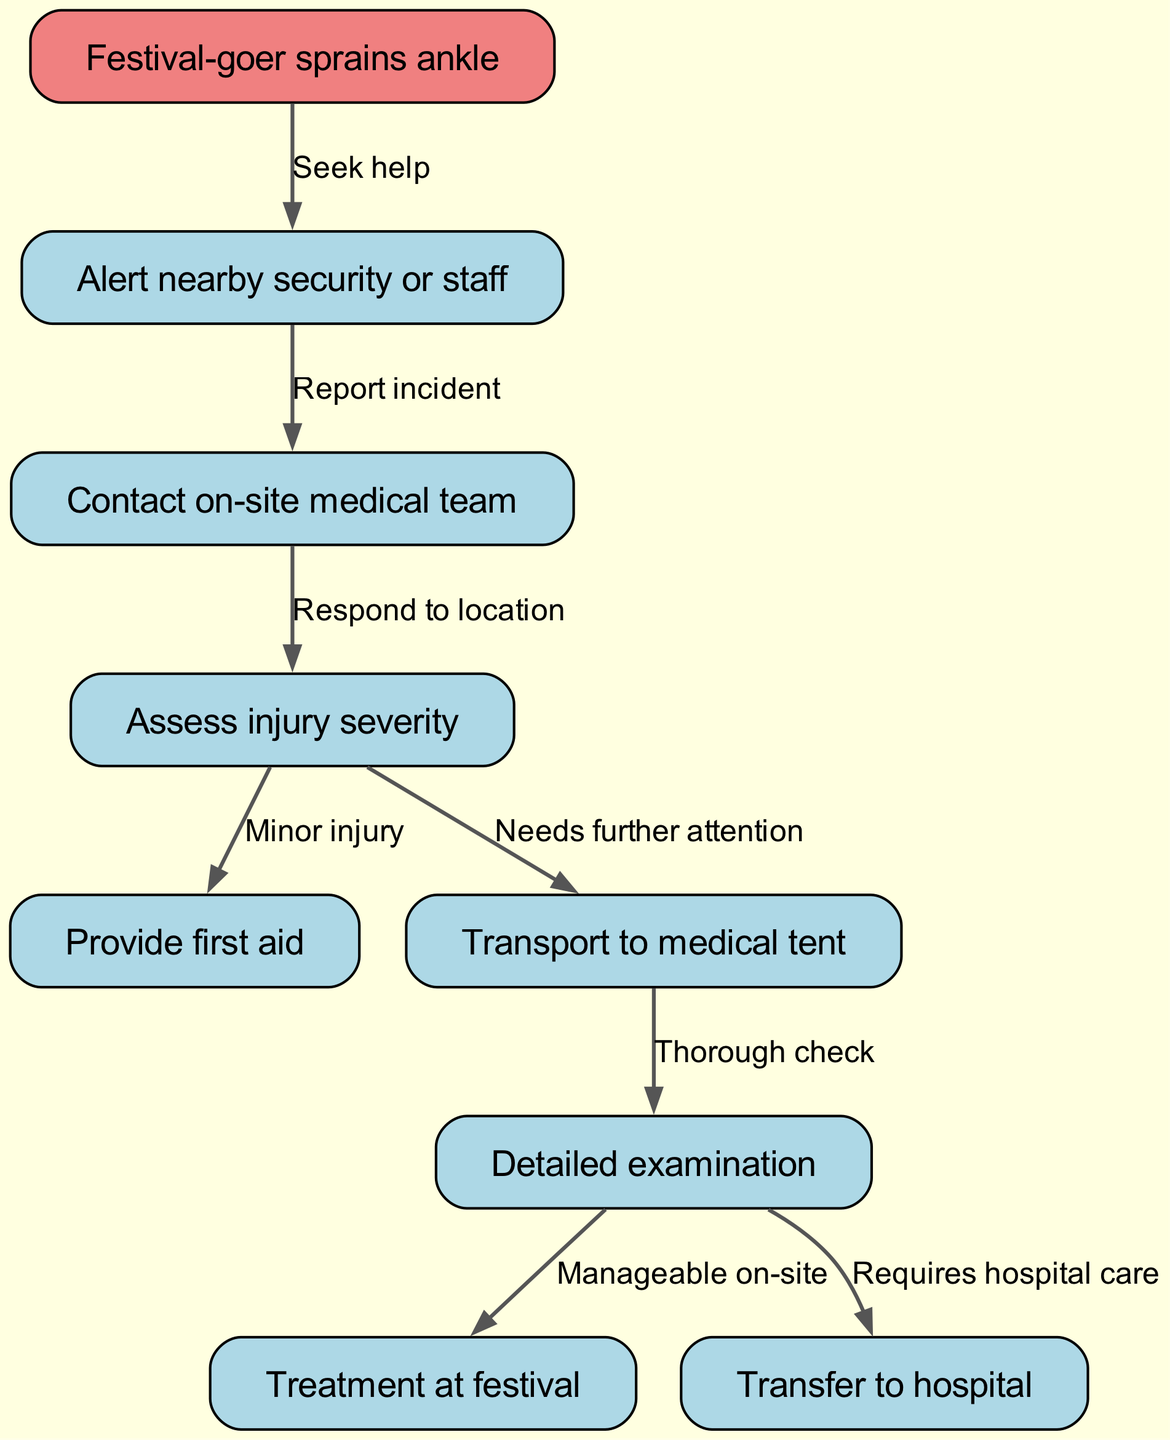What is the first step after a festival-goer sprains their ankle? The diagram indicates the first action is to alert nearby security or staff after the injury occurs. This is the first flow from the initial node.
Answer: Alert nearby security or staff How many nodes are present in the diagram? Counting the nodes listed, there are a total of nine nodes that represent different steps in the emergency medical response procedures at music festivals.
Answer: Nine What does the edge from "Assess injury severity" lead to if the injury is deemed a minor injury? The diagram shows that if the assessment determines a minor injury, the next step is to provide first aid. This is indicated by the connecting edge from node "4" to node "5".
Answer: Provide first aid What happens after the on-site medical team responds to the location? According to the diagram, responding to the location allows the team to assess the injury's severity, which follows from the initial contact with the medical team.
Answer: Assess injury severity If a detailed examination is required, what is the next step? The flow indicates that following a detailed examination, if the injury can be managed on-site, the team will proceed to provide treatment at the festival. This occurs after assessing the injury severity.
Answer: Treatment at festival What action is taken if the injury needs further attention? The diagram specifies that if the injury requires further attention, the next step is to transport the injured festival-goer to the medical tent for comprehensive care.
Answer: Transport to medical tent Which node follows the "Transport to medical tent" node? After the transportation to the medical tent, the next action depicted in the diagram is a detailed examination of the injury to determine the appropriate course of action.
Answer: Detailed examination What is the outcome if the treatment required is manageable on-site? The diagram indicates that if the treatment is manageable on-site, the team will provide treatment at the festival, which is the next logical step after examination.
Answer: Treatment at festival What connects "Detailed examination" to "Requires hospital care"? The edge from "Detailed examination" determines the necessity for transfer to a hospital based on the severity of the injury as assessed. If the injury is severe, that node leads to the option of hospital transfer.
Answer: Transfer to hospital 